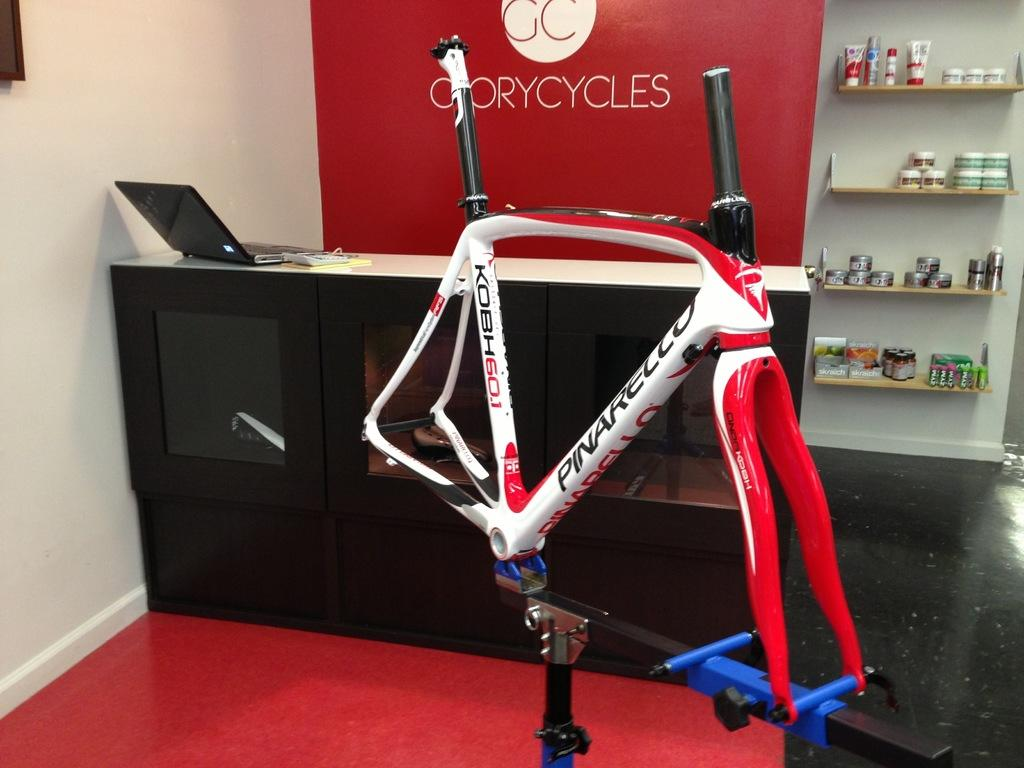<image>
Describe the image concisely. A laptop is sitting open on a reception desk that is in front of a red wall with the name of the establishment, called Cory Cycles, on it. 